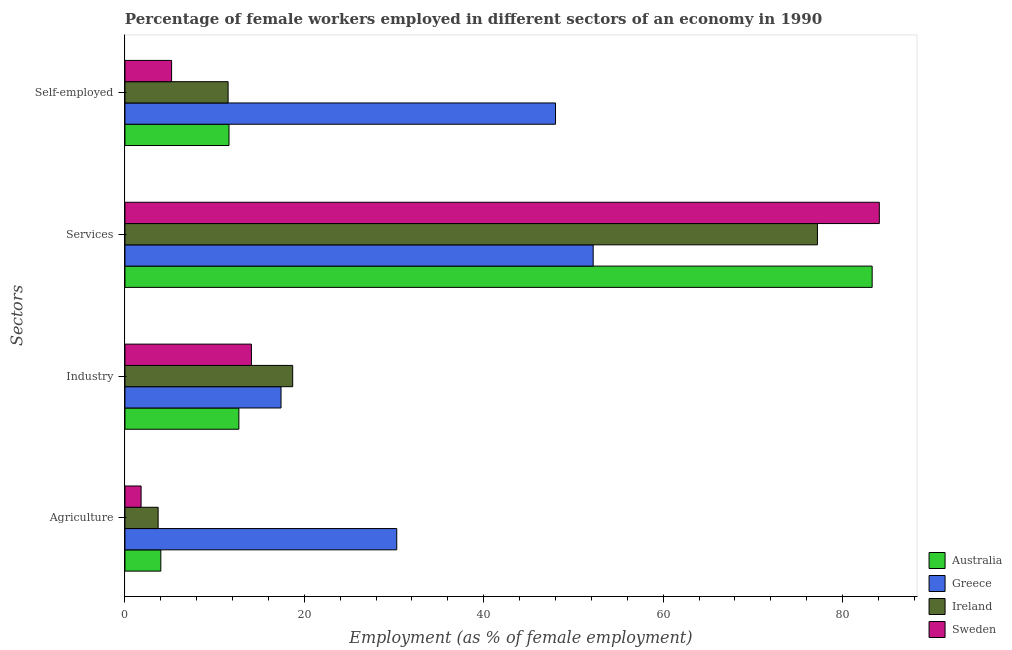How many different coloured bars are there?
Your response must be concise. 4. Are the number of bars per tick equal to the number of legend labels?
Your answer should be very brief. Yes. How many bars are there on the 2nd tick from the top?
Make the answer very short. 4. What is the label of the 1st group of bars from the top?
Keep it short and to the point. Self-employed. What is the percentage of female workers in services in Australia?
Offer a very short reply. 83.3. Across all countries, what is the maximum percentage of female workers in services?
Make the answer very short. 84.1. Across all countries, what is the minimum percentage of female workers in agriculture?
Ensure brevity in your answer.  1.8. In which country was the percentage of female workers in industry minimum?
Provide a succinct answer. Australia. What is the total percentage of female workers in industry in the graph?
Your answer should be compact. 62.9. What is the difference between the percentage of self employed female workers in Sweden and that in Australia?
Ensure brevity in your answer.  -6.4. What is the difference between the percentage of female workers in agriculture in Ireland and the percentage of female workers in industry in Australia?
Offer a very short reply. -9. What is the average percentage of female workers in industry per country?
Make the answer very short. 15.73. What is the difference between the percentage of self employed female workers and percentage of female workers in agriculture in Australia?
Your answer should be very brief. 7.6. In how many countries, is the percentage of female workers in agriculture greater than 56 %?
Your answer should be very brief. 0. What is the ratio of the percentage of self employed female workers in Sweden to that in Ireland?
Provide a short and direct response. 0.45. Is the percentage of female workers in services in Australia less than that in Sweden?
Offer a terse response. Yes. What is the difference between the highest and the second highest percentage of female workers in agriculture?
Give a very brief answer. 26.3. What is the difference between the highest and the lowest percentage of female workers in services?
Your answer should be compact. 31.9. Is it the case that in every country, the sum of the percentage of female workers in industry and percentage of female workers in services is greater than the sum of percentage of female workers in agriculture and percentage of self employed female workers?
Your response must be concise. Yes. What does the 3rd bar from the bottom in Agriculture represents?
Your answer should be very brief. Ireland. How many bars are there?
Your answer should be very brief. 16. Are all the bars in the graph horizontal?
Provide a succinct answer. Yes. How many countries are there in the graph?
Your answer should be very brief. 4. Are the values on the major ticks of X-axis written in scientific E-notation?
Ensure brevity in your answer.  No. Does the graph contain any zero values?
Your answer should be very brief. No. How many legend labels are there?
Give a very brief answer. 4. How are the legend labels stacked?
Your response must be concise. Vertical. What is the title of the graph?
Your response must be concise. Percentage of female workers employed in different sectors of an economy in 1990. What is the label or title of the X-axis?
Ensure brevity in your answer.  Employment (as % of female employment). What is the label or title of the Y-axis?
Offer a terse response. Sectors. What is the Employment (as % of female employment) in Greece in Agriculture?
Your response must be concise. 30.3. What is the Employment (as % of female employment) in Ireland in Agriculture?
Offer a very short reply. 3.7. What is the Employment (as % of female employment) of Sweden in Agriculture?
Your answer should be very brief. 1.8. What is the Employment (as % of female employment) of Australia in Industry?
Provide a succinct answer. 12.7. What is the Employment (as % of female employment) in Greece in Industry?
Make the answer very short. 17.4. What is the Employment (as % of female employment) in Ireland in Industry?
Make the answer very short. 18.7. What is the Employment (as % of female employment) of Sweden in Industry?
Your answer should be compact. 14.1. What is the Employment (as % of female employment) in Australia in Services?
Your answer should be very brief. 83.3. What is the Employment (as % of female employment) of Greece in Services?
Offer a very short reply. 52.2. What is the Employment (as % of female employment) in Ireland in Services?
Your answer should be compact. 77.2. What is the Employment (as % of female employment) in Sweden in Services?
Make the answer very short. 84.1. What is the Employment (as % of female employment) of Australia in Self-employed?
Provide a short and direct response. 11.6. What is the Employment (as % of female employment) in Greece in Self-employed?
Ensure brevity in your answer.  48. What is the Employment (as % of female employment) in Sweden in Self-employed?
Make the answer very short. 5.2. Across all Sectors, what is the maximum Employment (as % of female employment) of Australia?
Make the answer very short. 83.3. Across all Sectors, what is the maximum Employment (as % of female employment) in Greece?
Your answer should be compact. 52.2. Across all Sectors, what is the maximum Employment (as % of female employment) of Ireland?
Keep it short and to the point. 77.2. Across all Sectors, what is the maximum Employment (as % of female employment) in Sweden?
Your response must be concise. 84.1. Across all Sectors, what is the minimum Employment (as % of female employment) in Greece?
Your response must be concise. 17.4. Across all Sectors, what is the minimum Employment (as % of female employment) of Ireland?
Keep it short and to the point. 3.7. Across all Sectors, what is the minimum Employment (as % of female employment) in Sweden?
Offer a terse response. 1.8. What is the total Employment (as % of female employment) in Australia in the graph?
Give a very brief answer. 111.6. What is the total Employment (as % of female employment) of Greece in the graph?
Keep it short and to the point. 147.9. What is the total Employment (as % of female employment) in Ireland in the graph?
Provide a short and direct response. 111.1. What is the total Employment (as % of female employment) in Sweden in the graph?
Provide a short and direct response. 105.2. What is the difference between the Employment (as % of female employment) of Greece in Agriculture and that in Industry?
Keep it short and to the point. 12.9. What is the difference between the Employment (as % of female employment) of Australia in Agriculture and that in Services?
Your answer should be very brief. -79.3. What is the difference between the Employment (as % of female employment) in Greece in Agriculture and that in Services?
Ensure brevity in your answer.  -21.9. What is the difference between the Employment (as % of female employment) in Ireland in Agriculture and that in Services?
Offer a terse response. -73.5. What is the difference between the Employment (as % of female employment) in Sweden in Agriculture and that in Services?
Ensure brevity in your answer.  -82.3. What is the difference between the Employment (as % of female employment) of Greece in Agriculture and that in Self-employed?
Offer a terse response. -17.7. What is the difference between the Employment (as % of female employment) of Australia in Industry and that in Services?
Provide a succinct answer. -70.6. What is the difference between the Employment (as % of female employment) of Greece in Industry and that in Services?
Your response must be concise. -34.8. What is the difference between the Employment (as % of female employment) of Ireland in Industry and that in Services?
Ensure brevity in your answer.  -58.5. What is the difference between the Employment (as % of female employment) in Sweden in Industry and that in Services?
Provide a succinct answer. -70. What is the difference between the Employment (as % of female employment) in Australia in Industry and that in Self-employed?
Ensure brevity in your answer.  1.1. What is the difference between the Employment (as % of female employment) of Greece in Industry and that in Self-employed?
Offer a very short reply. -30.6. What is the difference between the Employment (as % of female employment) of Ireland in Industry and that in Self-employed?
Offer a terse response. 7.2. What is the difference between the Employment (as % of female employment) of Australia in Services and that in Self-employed?
Your answer should be compact. 71.7. What is the difference between the Employment (as % of female employment) in Ireland in Services and that in Self-employed?
Your answer should be very brief. 65.7. What is the difference between the Employment (as % of female employment) in Sweden in Services and that in Self-employed?
Offer a terse response. 78.9. What is the difference between the Employment (as % of female employment) of Australia in Agriculture and the Employment (as % of female employment) of Ireland in Industry?
Your answer should be very brief. -14.7. What is the difference between the Employment (as % of female employment) in Greece in Agriculture and the Employment (as % of female employment) in Ireland in Industry?
Provide a succinct answer. 11.6. What is the difference between the Employment (as % of female employment) of Ireland in Agriculture and the Employment (as % of female employment) of Sweden in Industry?
Your answer should be very brief. -10.4. What is the difference between the Employment (as % of female employment) in Australia in Agriculture and the Employment (as % of female employment) in Greece in Services?
Ensure brevity in your answer.  -48.2. What is the difference between the Employment (as % of female employment) in Australia in Agriculture and the Employment (as % of female employment) in Ireland in Services?
Provide a short and direct response. -73.2. What is the difference between the Employment (as % of female employment) in Australia in Agriculture and the Employment (as % of female employment) in Sweden in Services?
Your answer should be very brief. -80.1. What is the difference between the Employment (as % of female employment) of Greece in Agriculture and the Employment (as % of female employment) of Ireland in Services?
Make the answer very short. -46.9. What is the difference between the Employment (as % of female employment) of Greece in Agriculture and the Employment (as % of female employment) of Sweden in Services?
Make the answer very short. -53.8. What is the difference between the Employment (as % of female employment) of Ireland in Agriculture and the Employment (as % of female employment) of Sweden in Services?
Provide a short and direct response. -80.4. What is the difference between the Employment (as % of female employment) in Australia in Agriculture and the Employment (as % of female employment) in Greece in Self-employed?
Your answer should be compact. -44. What is the difference between the Employment (as % of female employment) of Australia in Agriculture and the Employment (as % of female employment) of Ireland in Self-employed?
Your answer should be compact. -7.5. What is the difference between the Employment (as % of female employment) of Australia in Agriculture and the Employment (as % of female employment) of Sweden in Self-employed?
Offer a terse response. -1.2. What is the difference between the Employment (as % of female employment) of Greece in Agriculture and the Employment (as % of female employment) of Ireland in Self-employed?
Your response must be concise. 18.8. What is the difference between the Employment (as % of female employment) in Greece in Agriculture and the Employment (as % of female employment) in Sweden in Self-employed?
Your answer should be compact. 25.1. What is the difference between the Employment (as % of female employment) in Ireland in Agriculture and the Employment (as % of female employment) in Sweden in Self-employed?
Your answer should be very brief. -1.5. What is the difference between the Employment (as % of female employment) of Australia in Industry and the Employment (as % of female employment) of Greece in Services?
Provide a succinct answer. -39.5. What is the difference between the Employment (as % of female employment) of Australia in Industry and the Employment (as % of female employment) of Ireland in Services?
Make the answer very short. -64.5. What is the difference between the Employment (as % of female employment) of Australia in Industry and the Employment (as % of female employment) of Sweden in Services?
Your response must be concise. -71.4. What is the difference between the Employment (as % of female employment) in Greece in Industry and the Employment (as % of female employment) in Ireland in Services?
Your answer should be compact. -59.8. What is the difference between the Employment (as % of female employment) of Greece in Industry and the Employment (as % of female employment) of Sweden in Services?
Provide a short and direct response. -66.7. What is the difference between the Employment (as % of female employment) in Ireland in Industry and the Employment (as % of female employment) in Sweden in Services?
Your answer should be compact. -65.4. What is the difference between the Employment (as % of female employment) in Australia in Industry and the Employment (as % of female employment) in Greece in Self-employed?
Provide a succinct answer. -35.3. What is the difference between the Employment (as % of female employment) of Australia in Industry and the Employment (as % of female employment) of Sweden in Self-employed?
Keep it short and to the point. 7.5. What is the difference between the Employment (as % of female employment) of Ireland in Industry and the Employment (as % of female employment) of Sweden in Self-employed?
Provide a succinct answer. 13.5. What is the difference between the Employment (as % of female employment) of Australia in Services and the Employment (as % of female employment) of Greece in Self-employed?
Give a very brief answer. 35.3. What is the difference between the Employment (as % of female employment) of Australia in Services and the Employment (as % of female employment) of Ireland in Self-employed?
Give a very brief answer. 71.8. What is the difference between the Employment (as % of female employment) in Australia in Services and the Employment (as % of female employment) in Sweden in Self-employed?
Ensure brevity in your answer.  78.1. What is the difference between the Employment (as % of female employment) of Greece in Services and the Employment (as % of female employment) of Ireland in Self-employed?
Your response must be concise. 40.7. What is the average Employment (as % of female employment) of Australia per Sectors?
Offer a very short reply. 27.9. What is the average Employment (as % of female employment) in Greece per Sectors?
Your response must be concise. 36.98. What is the average Employment (as % of female employment) of Ireland per Sectors?
Keep it short and to the point. 27.77. What is the average Employment (as % of female employment) of Sweden per Sectors?
Offer a very short reply. 26.3. What is the difference between the Employment (as % of female employment) in Australia and Employment (as % of female employment) in Greece in Agriculture?
Your answer should be compact. -26.3. What is the difference between the Employment (as % of female employment) of Australia and Employment (as % of female employment) of Ireland in Agriculture?
Your answer should be very brief. 0.3. What is the difference between the Employment (as % of female employment) of Greece and Employment (as % of female employment) of Ireland in Agriculture?
Your response must be concise. 26.6. What is the difference between the Employment (as % of female employment) in Ireland and Employment (as % of female employment) in Sweden in Agriculture?
Offer a terse response. 1.9. What is the difference between the Employment (as % of female employment) in Australia and Employment (as % of female employment) in Greece in Industry?
Offer a very short reply. -4.7. What is the difference between the Employment (as % of female employment) of Australia and Employment (as % of female employment) of Ireland in Industry?
Offer a terse response. -6. What is the difference between the Employment (as % of female employment) of Australia and Employment (as % of female employment) of Sweden in Industry?
Make the answer very short. -1.4. What is the difference between the Employment (as % of female employment) of Greece and Employment (as % of female employment) of Ireland in Industry?
Offer a terse response. -1.3. What is the difference between the Employment (as % of female employment) in Greece and Employment (as % of female employment) in Sweden in Industry?
Your answer should be compact. 3.3. What is the difference between the Employment (as % of female employment) in Australia and Employment (as % of female employment) in Greece in Services?
Offer a terse response. 31.1. What is the difference between the Employment (as % of female employment) of Australia and Employment (as % of female employment) of Sweden in Services?
Offer a terse response. -0.8. What is the difference between the Employment (as % of female employment) of Greece and Employment (as % of female employment) of Ireland in Services?
Your answer should be compact. -25. What is the difference between the Employment (as % of female employment) in Greece and Employment (as % of female employment) in Sweden in Services?
Make the answer very short. -31.9. What is the difference between the Employment (as % of female employment) in Australia and Employment (as % of female employment) in Greece in Self-employed?
Offer a terse response. -36.4. What is the difference between the Employment (as % of female employment) in Australia and Employment (as % of female employment) in Ireland in Self-employed?
Give a very brief answer. 0.1. What is the difference between the Employment (as % of female employment) in Greece and Employment (as % of female employment) in Ireland in Self-employed?
Offer a terse response. 36.5. What is the difference between the Employment (as % of female employment) in Greece and Employment (as % of female employment) in Sweden in Self-employed?
Your response must be concise. 42.8. What is the difference between the Employment (as % of female employment) of Ireland and Employment (as % of female employment) of Sweden in Self-employed?
Provide a short and direct response. 6.3. What is the ratio of the Employment (as % of female employment) in Australia in Agriculture to that in Industry?
Provide a succinct answer. 0.32. What is the ratio of the Employment (as % of female employment) in Greece in Agriculture to that in Industry?
Provide a short and direct response. 1.74. What is the ratio of the Employment (as % of female employment) of Ireland in Agriculture to that in Industry?
Your answer should be compact. 0.2. What is the ratio of the Employment (as % of female employment) of Sweden in Agriculture to that in Industry?
Provide a short and direct response. 0.13. What is the ratio of the Employment (as % of female employment) of Australia in Agriculture to that in Services?
Provide a short and direct response. 0.05. What is the ratio of the Employment (as % of female employment) of Greece in Agriculture to that in Services?
Offer a terse response. 0.58. What is the ratio of the Employment (as % of female employment) of Ireland in Agriculture to that in Services?
Give a very brief answer. 0.05. What is the ratio of the Employment (as % of female employment) in Sweden in Agriculture to that in Services?
Make the answer very short. 0.02. What is the ratio of the Employment (as % of female employment) of Australia in Agriculture to that in Self-employed?
Your answer should be compact. 0.34. What is the ratio of the Employment (as % of female employment) in Greece in Agriculture to that in Self-employed?
Provide a succinct answer. 0.63. What is the ratio of the Employment (as % of female employment) of Ireland in Agriculture to that in Self-employed?
Your response must be concise. 0.32. What is the ratio of the Employment (as % of female employment) in Sweden in Agriculture to that in Self-employed?
Keep it short and to the point. 0.35. What is the ratio of the Employment (as % of female employment) of Australia in Industry to that in Services?
Keep it short and to the point. 0.15. What is the ratio of the Employment (as % of female employment) in Greece in Industry to that in Services?
Your response must be concise. 0.33. What is the ratio of the Employment (as % of female employment) of Ireland in Industry to that in Services?
Give a very brief answer. 0.24. What is the ratio of the Employment (as % of female employment) in Sweden in Industry to that in Services?
Offer a terse response. 0.17. What is the ratio of the Employment (as % of female employment) in Australia in Industry to that in Self-employed?
Your answer should be compact. 1.09. What is the ratio of the Employment (as % of female employment) in Greece in Industry to that in Self-employed?
Keep it short and to the point. 0.36. What is the ratio of the Employment (as % of female employment) in Ireland in Industry to that in Self-employed?
Provide a succinct answer. 1.63. What is the ratio of the Employment (as % of female employment) of Sweden in Industry to that in Self-employed?
Ensure brevity in your answer.  2.71. What is the ratio of the Employment (as % of female employment) in Australia in Services to that in Self-employed?
Make the answer very short. 7.18. What is the ratio of the Employment (as % of female employment) in Greece in Services to that in Self-employed?
Make the answer very short. 1.09. What is the ratio of the Employment (as % of female employment) in Ireland in Services to that in Self-employed?
Your answer should be very brief. 6.71. What is the ratio of the Employment (as % of female employment) in Sweden in Services to that in Self-employed?
Provide a short and direct response. 16.17. What is the difference between the highest and the second highest Employment (as % of female employment) in Australia?
Offer a terse response. 70.6. What is the difference between the highest and the second highest Employment (as % of female employment) in Ireland?
Make the answer very short. 58.5. What is the difference between the highest and the second highest Employment (as % of female employment) of Sweden?
Make the answer very short. 70. What is the difference between the highest and the lowest Employment (as % of female employment) in Australia?
Make the answer very short. 79.3. What is the difference between the highest and the lowest Employment (as % of female employment) of Greece?
Your answer should be compact. 34.8. What is the difference between the highest and the lowest Employment (as % of female employment) of Ireland?
Keep it short and to the point. 73.5. What is the difference between the highest and the lowest Employment (as % of female employment) of Sweden?
Offer a terse response. 82.3. 